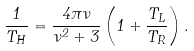Convert formula to latex. <formula><loc_0><loc_0><loc_500><loc_500>\frac { 1 } { T _ { H } } = \frac { 4 \pi \nu } { \nu ^ { 2 } + 3 } \left ( 1 + \frac { T _ { L } } { T _ { R } } \right ) .</formula> 